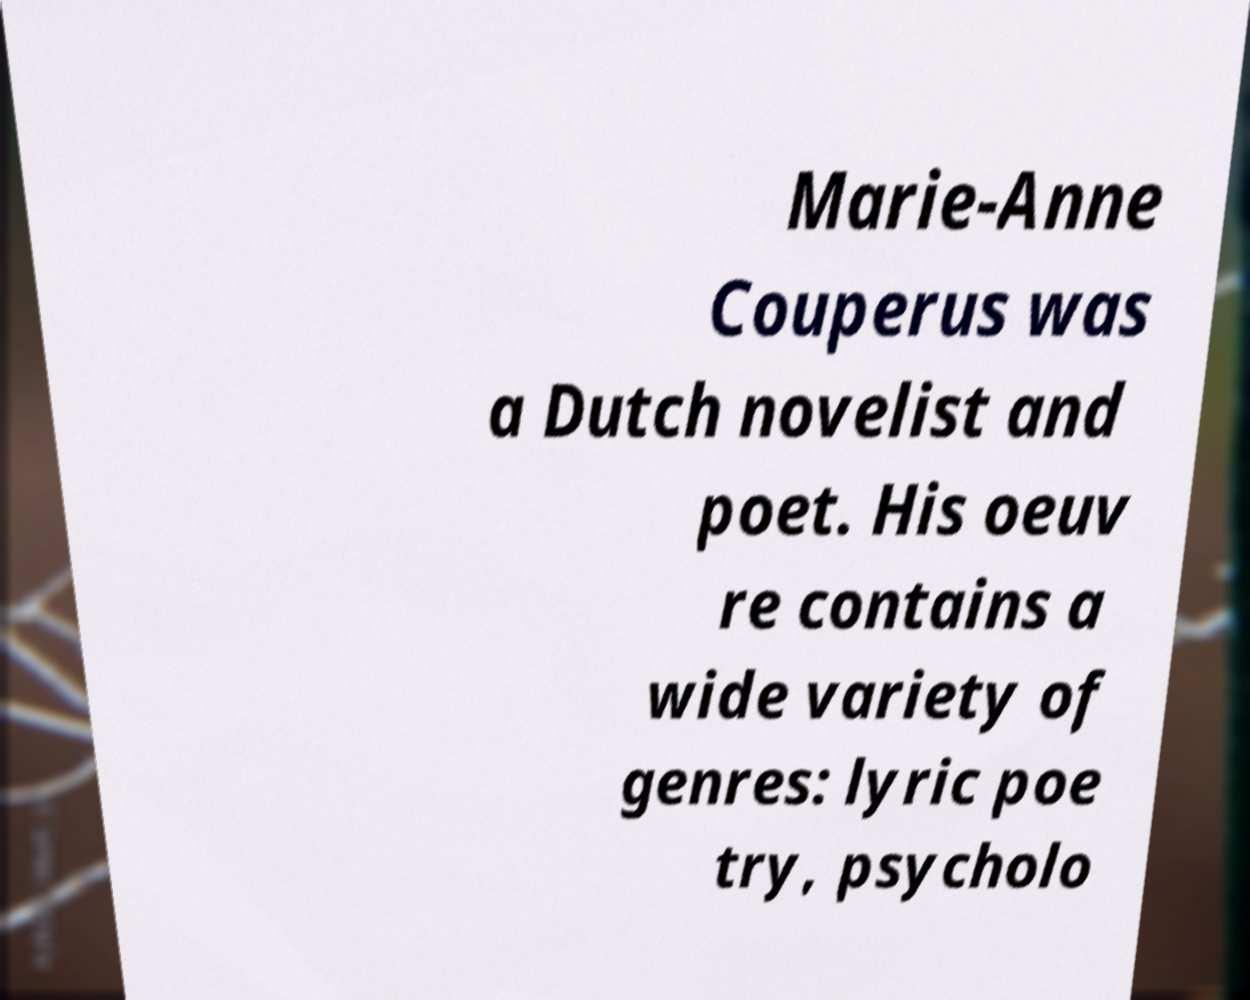Please read and relay the text visible in this image. What does it say? Marie-Anne Couperus was a Dutch novelist and poet. His oeuv re contains a wide variety of genres: lyric poe try, psycholo 